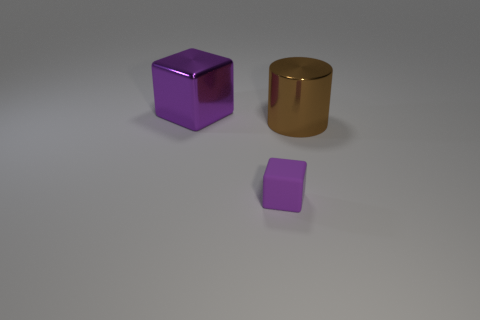There is a big object on the right side of the tiny purple thing; what number of large blocks are left of it?
Your answer should be very brief. 1. Does the large object in front of the metallic block have the same color as the tiny block?
Your answer should be compact. No. How many things are either shiny cylinders or cubes behind the big brown metal object?
Your answer should be compact. 2. There is a purple metallic object that is to the left of the big brown metal object; is it the same shape as the thing that is in front of the large metal cylinder?
Your response must be concise. Yes. Are there any other things that have the same color as the tiny matte thing?
Make the answer very short. Yes. What shape is the other big object that is made of the same material as the brown object?
Keep it short and to the point. Cube. What is the material of the object that is both right of the big purple shiny cube and to the left of the big brown thing?
Offer a very short reply. Rubber. Is there any other thing that has the same size as the shiny cylinder?
Give a very brief answer. Yes. Do the small block and the metallic cylinder have the same color?
Your response must be concise. No. There is a shiny thing that is the same color as the small cube; what shape is it?
Your answer should be very brief. Cube. 